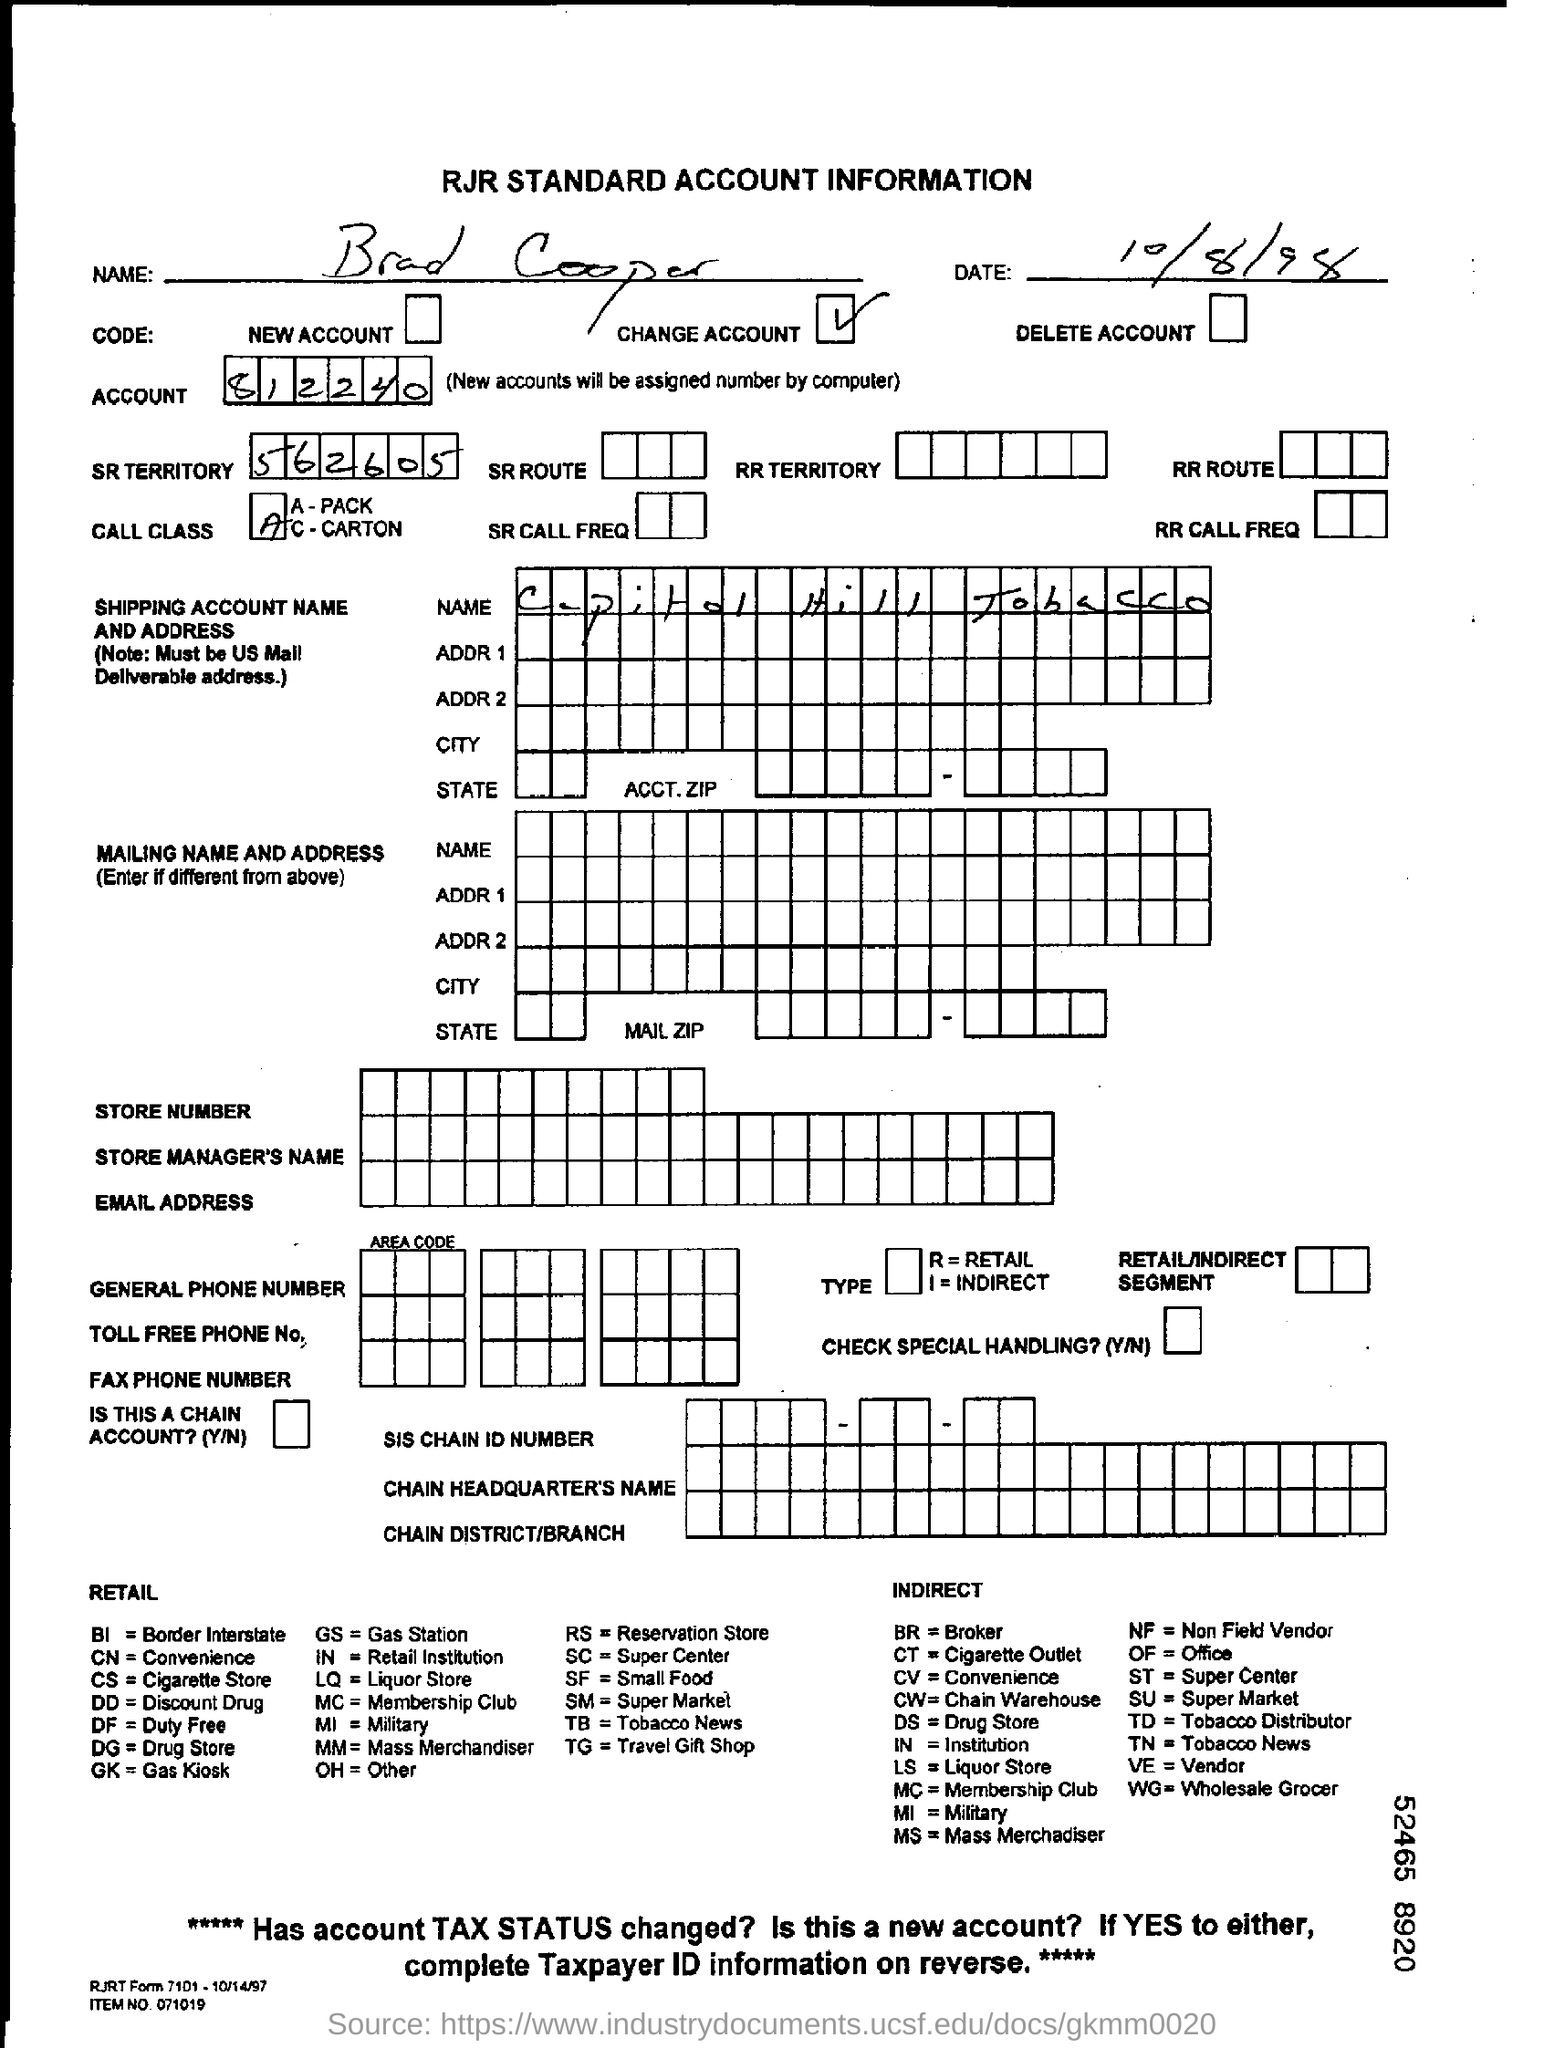List a handful of essential elements in this visual. The account number of Brad Cooper is 812240... The date in the account information is October 8, 1998. The person's name in the account information is Brad Cooper. The SR territory is 562605...," stated the speaker. The name of the shipping account is 'Capital Hill Tobacco.' 